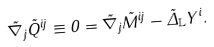<formula> <loc_0><loc_0><loc_500><loc_500>\tilde { \nabla } _ { j } \tilde { Q } ^ { i j } \equiv 0 = \tilde { \nabla } _ { j } \tilde { M } ^ { i j } - \tilde { \Delta } _ { \mathbb { L } } Y ^ { i } .</formula> 